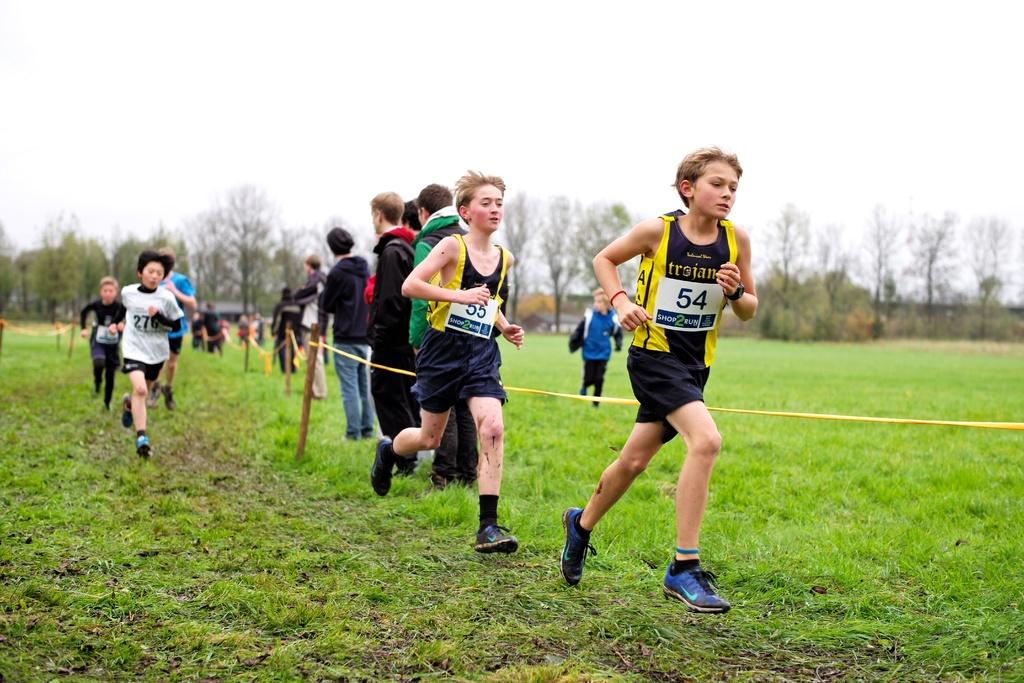What is the main subject of the image? The main subject of the image is a group of children. What are the children doing in the image? The children are running on the grass. What can be seen in the background of the image? There are trees in the background of the image. How fast are the dogs running in the image? There are no dogs present in the image; it features a group of children running on the grass. 